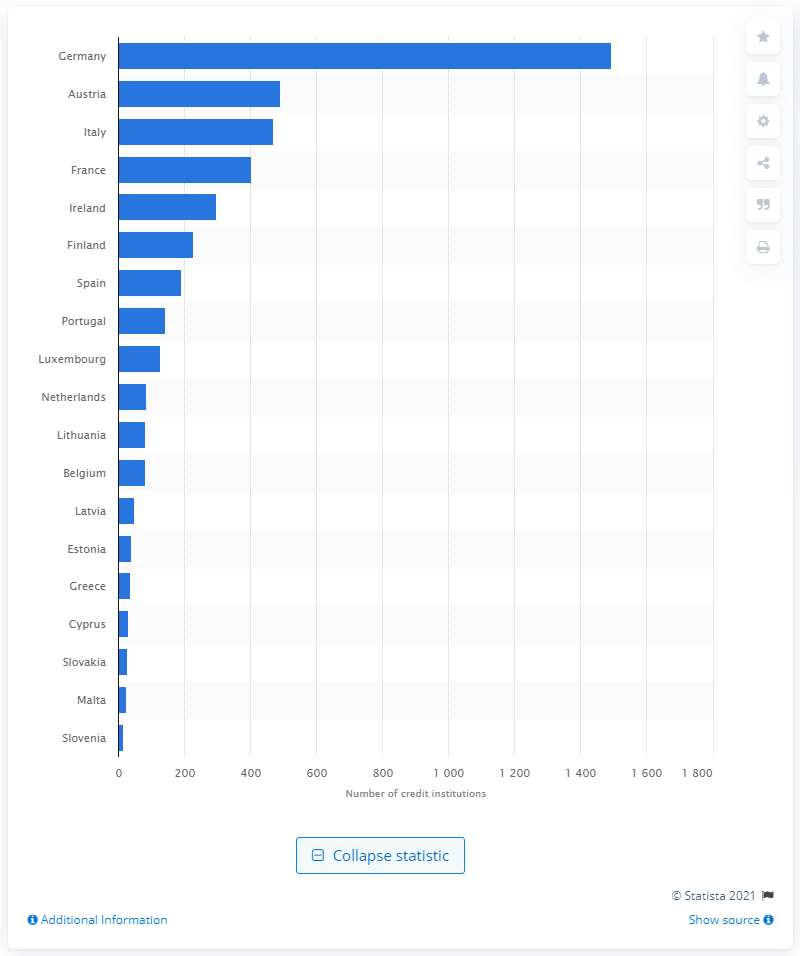Identify some key points in this picture. In February 2021, there were 492 credit institutions located in Austria. Austria had the largest number of MFI credit institutions in the Eurozone in February 2021. As of February 2021, Germany had the largest number of MFI credit institutions in the Eurozone. 